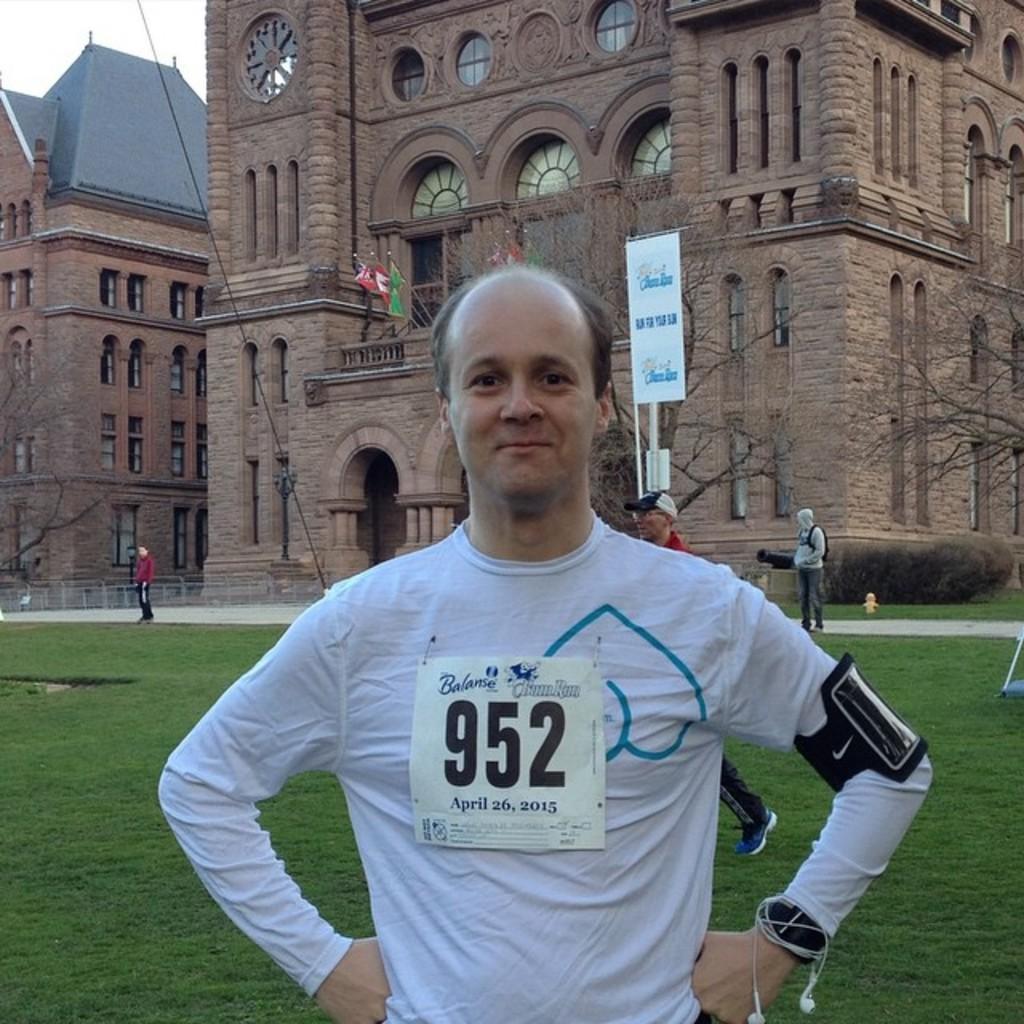In one or two sentences, can you explain what this image depicts? In this image I can see a person standing wearing white color shirt. Background I can see few persons standing, buildings in brown color and sky in white color. 